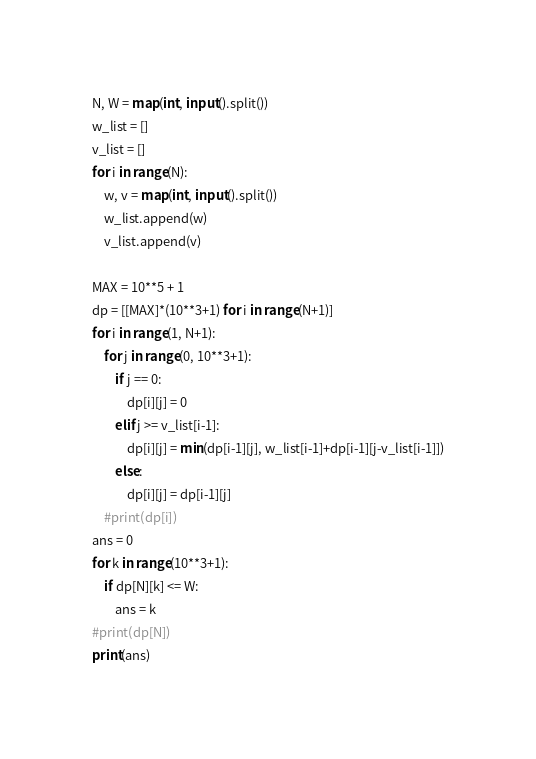Convert code to text. <code><loc_0><loc_0><loc_500><loc_500><_Python_>N, W = map(int, input().split())
w_list = []
v_list = []
for i in range(N):
    w, v = map(int, input().split())
    w_list.append(w)
    v_list.append(v)

MAX = 10**5 + 1
dp = [[MAX]*(10**3+1) for i in range(N+1)]
for i in range(1, N+1):
    for j in range(0, 10**3+1):
        if j == 0:
            dp[i][j] = 0
        elif j >= v_list[i-1]:
            dp[i][j] = min(dp[i-1][j], w_list[i-1]+dp[i-1][j-v_list[i-1]])
        else:
            dp[i][j] = dp[i-1][j]
    #print(dp[i]) 
ans = 0
for k in range(10**3+1):
    if dp[N][k] <= W:
        ans = k
#print(dp[N])
print(ans)</code> 